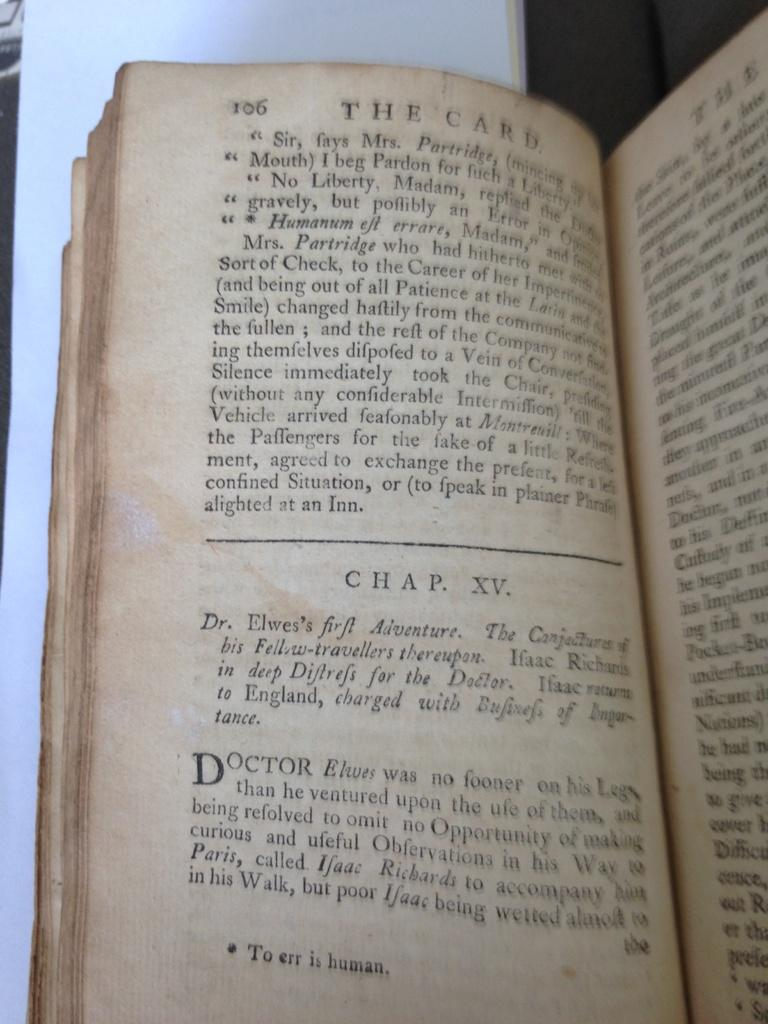<image>
Offer a succinct explanation of the picture presented. A book is open to page 106 of the story The Card. 